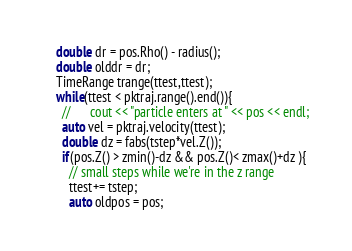<code> <loc_0><loc_0><loc_500><loc_500><_C++_>    double dr = pos.Rho() - radius();
    double olddr = dr;
    TimeRange trange(ttest,ttest);
    while(ttest < pktraj.range().end()){
      //      cout << "particle enters at " << pos << endl;
      auto vel = pktraj.velocity(ttest);
      double dz = fabs(tstep*vel.Z());
      if(pos.Z() > zmin()-dz && pos.Z()< zmax()+dz ){
        // small steps while we're in the z range
        ttest+= tstep;
        auto oldpos = pos;</code> 